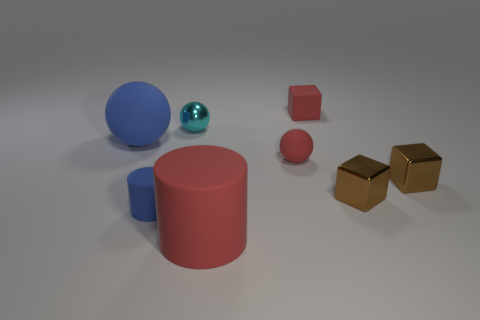What material is the tiny cyan thing?
Make the answer very short. Metal. Are there any small red things left of the tiny cyan object?
Give a very brief answer. No. Is the big blue matte thing the same shape as the tiny cyan shiny thing?
Your answer should be very brief. Yes. How many other objects are the same size as the blue rubber ball?
Your answer should be compact. 1. What number of things are matte balls that are to the right of the large red object or large red matte cylinders?
Offer a very short reply. 2. What color is the big cylinder?
Keep it short and to the point. Red. What is the tiny red thing that is in front of the small red block made of?
Make the answer very short. Rubber. There is a small cyan object; is it the same shape as the matte thing that is on the left side of the small matte cylinder?
Offer a very short reply. Yes. Are there more rubber cylinders than tiny red matte cubes?
Make the answer very short. Yes. Are there any other things that are the same color as the tiny metal sphere?
Your answer should be compact. No. 